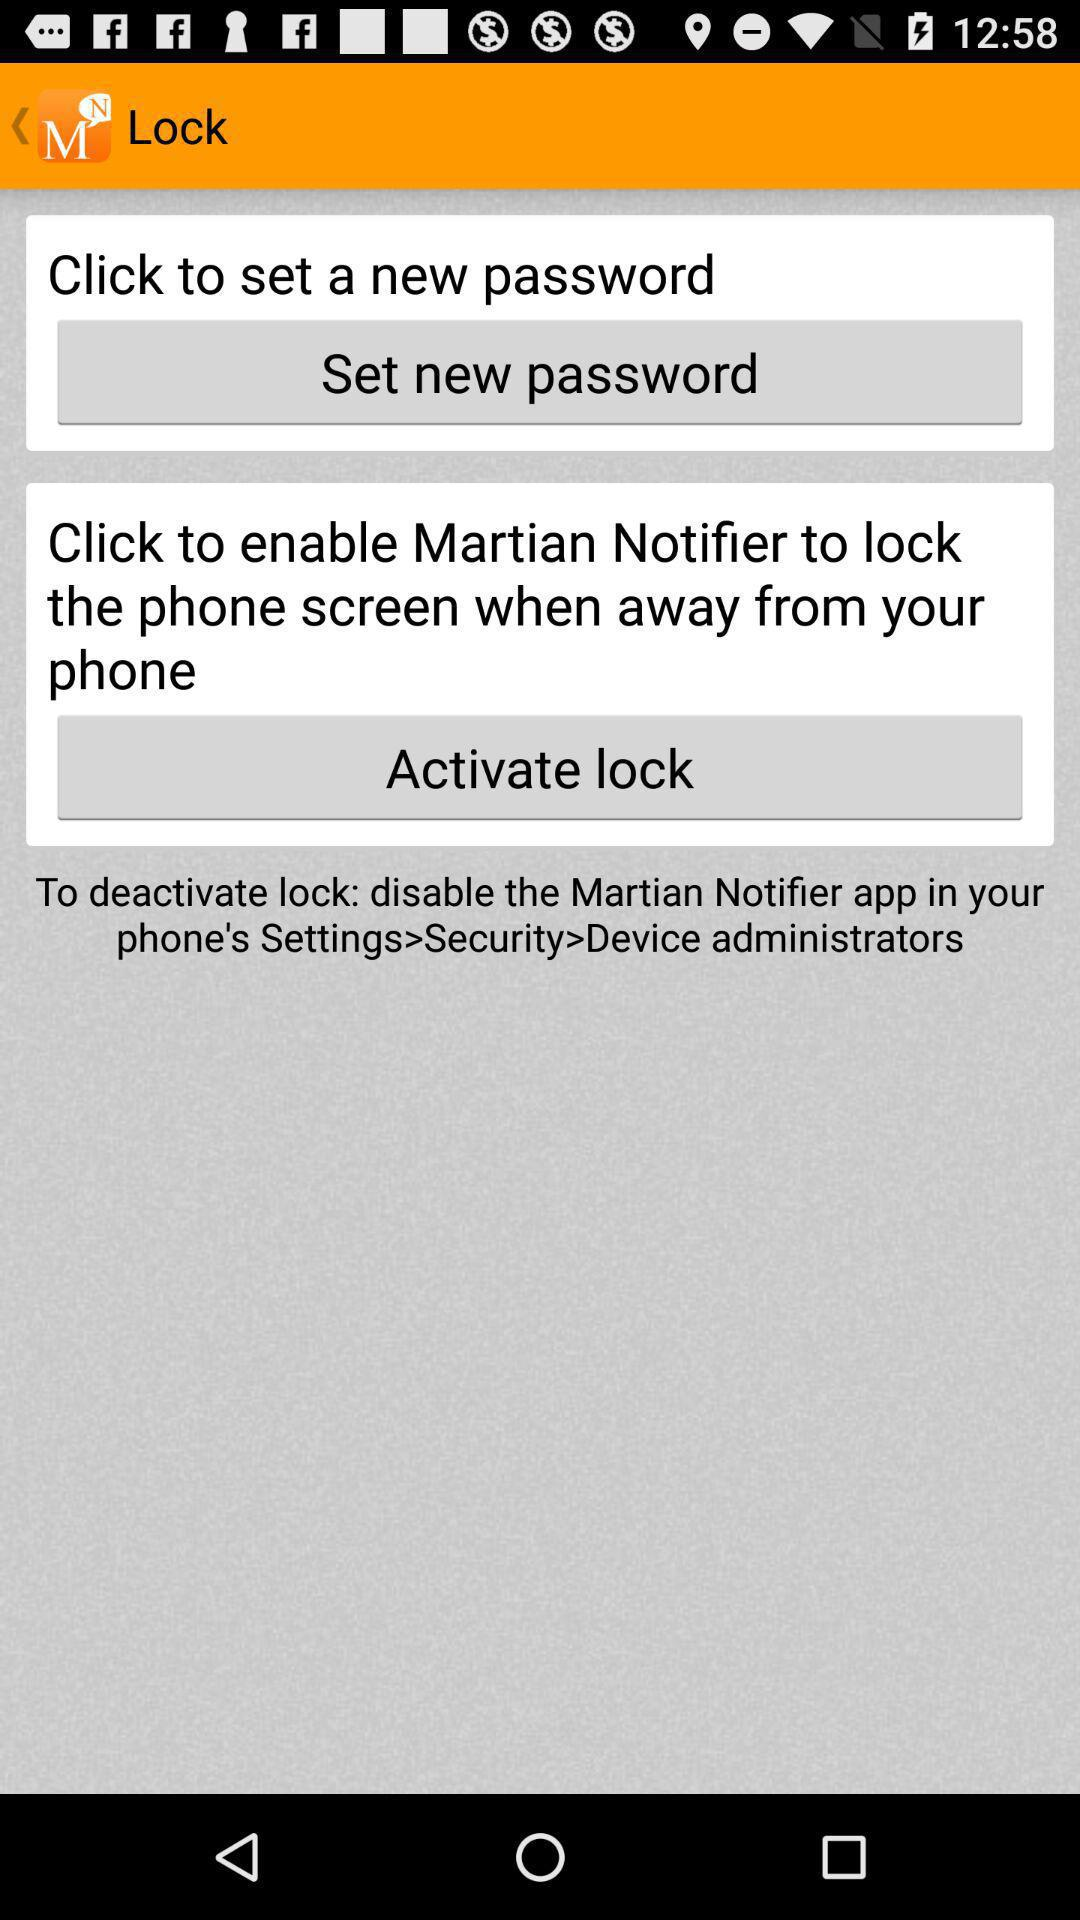What is the app name? The app name is "Martian Notifier". 